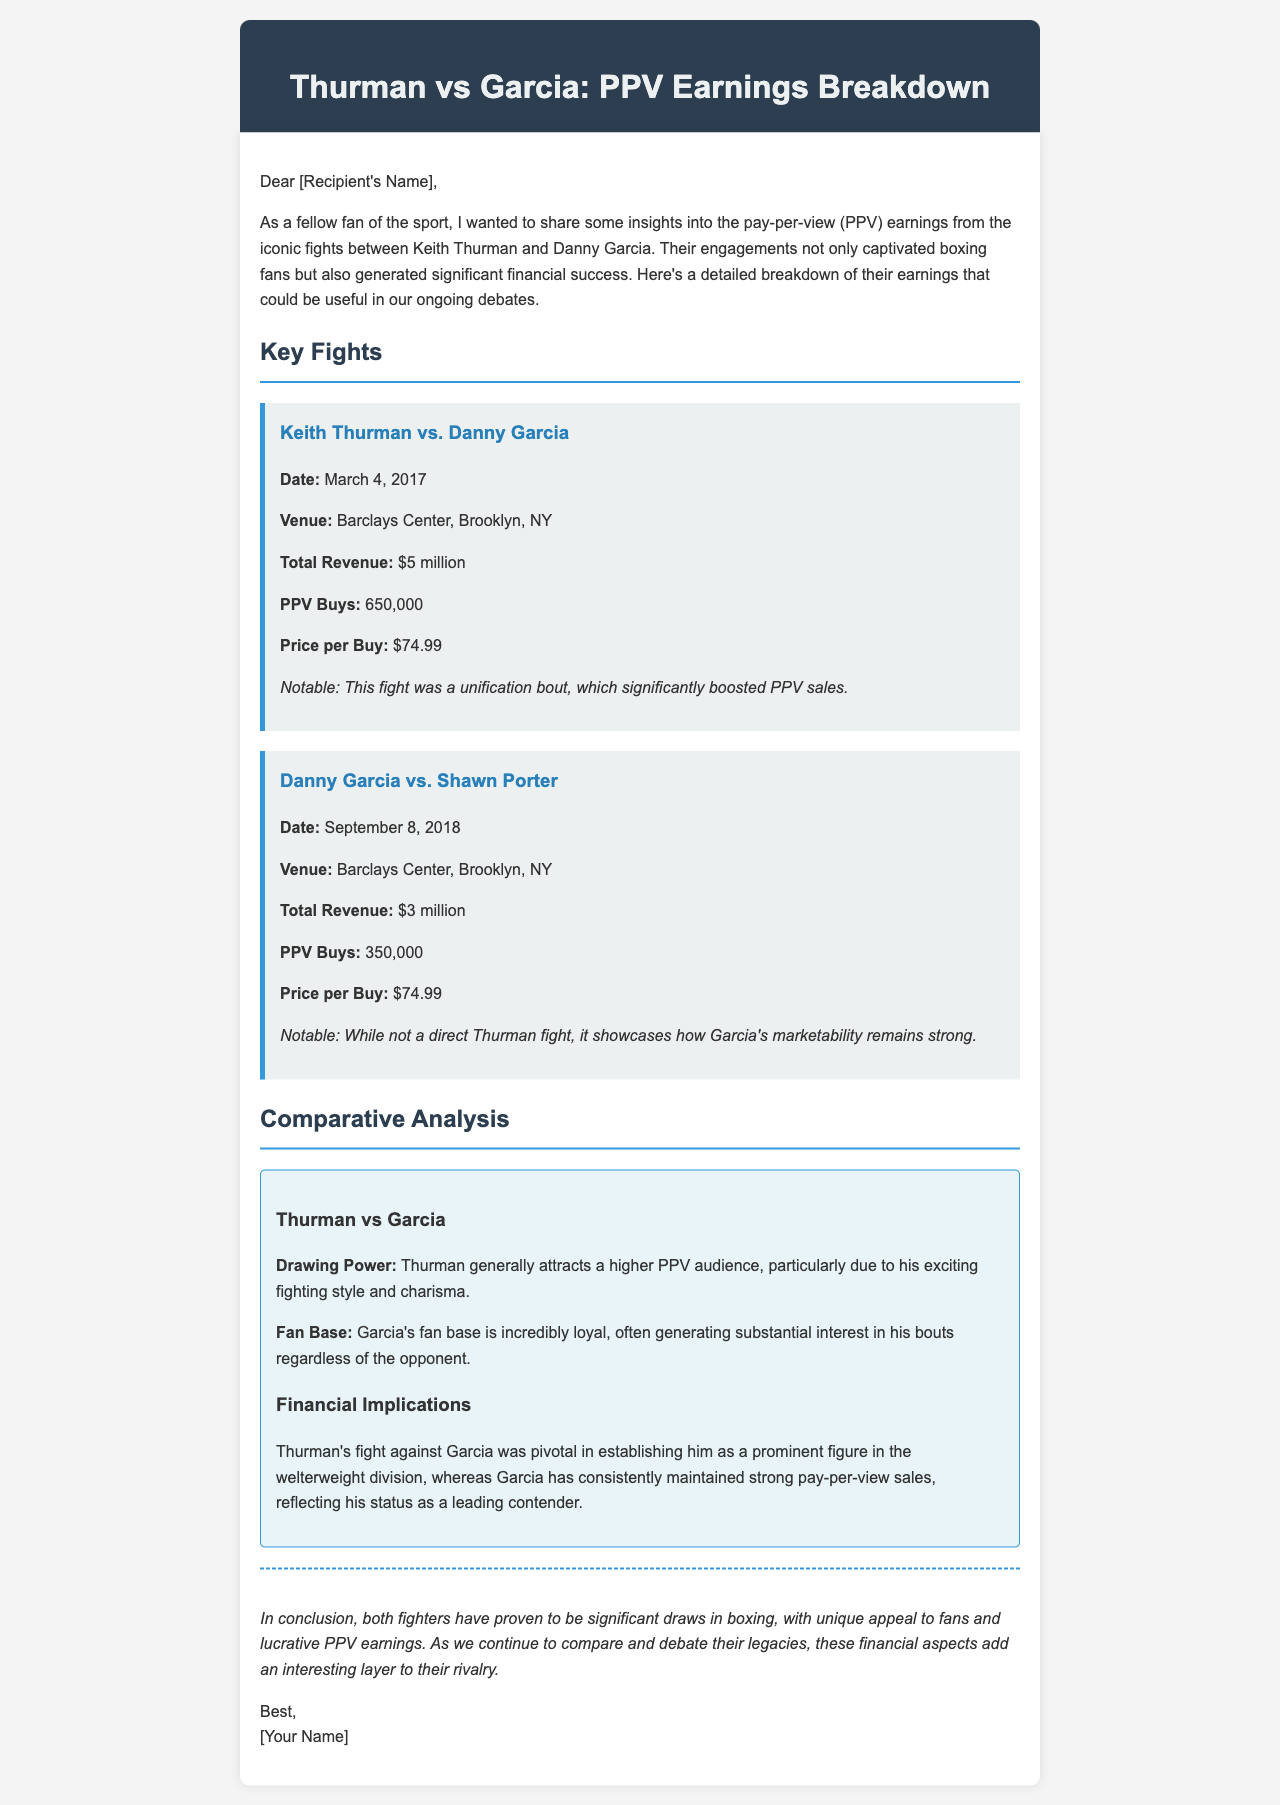what was the date of the Thurman-Garcia fight? The date of the fight between Keith Thurman and Danny Garcia is mentioned in the document as March 4, 2017.
Answer: March 4, 2017 what was the total revenue for the Thurman-Garcia fight? The total revenue generated from the Thurman-Garcia fight is provided in the document as $5 million.
Answer: $5 million how many PPV buys did the Thurman-Garcia fight generate? The number of PPV buys for the Thurman-Garcia fight is listed in the document as 650,000.
Answer: 650,000 what is the price per buy for the PPV? The document states the price per buy for the PPV is $74.99.
Answer: $74.99 who did Danny Garcia fight on September 8, 2018? The document mentions that Danny Garcia fought Shawn Porter on September 8, 2018.
Answer: Shawn Porter what does the analysis suggest about Thurman's drawing power? The document indicates that Thurman generally attracts a higher PPV audience due to his exciting fighting style and charisma.
Answer: Higher PPV audience how has Garcia's marketability been illustrated in the document? The document notes that Garcia's fight against Shawn Porter showcases his strong marketability, even when not facing Thurman.
Answer: Strong marketability what kind of bout was the Thurman vs Garcia fight described as? The document describes the Thurman vs Garcia fight as a unification bout, which significantly boosted PPV sales.
Answer: Unification bout what is the conclusion about both fighters? The document concludes that both fighters have proven to be significant draws in boxing with unique appeal to fans and lucrative PPV earnings.
Answer: Significant draws in boxing 